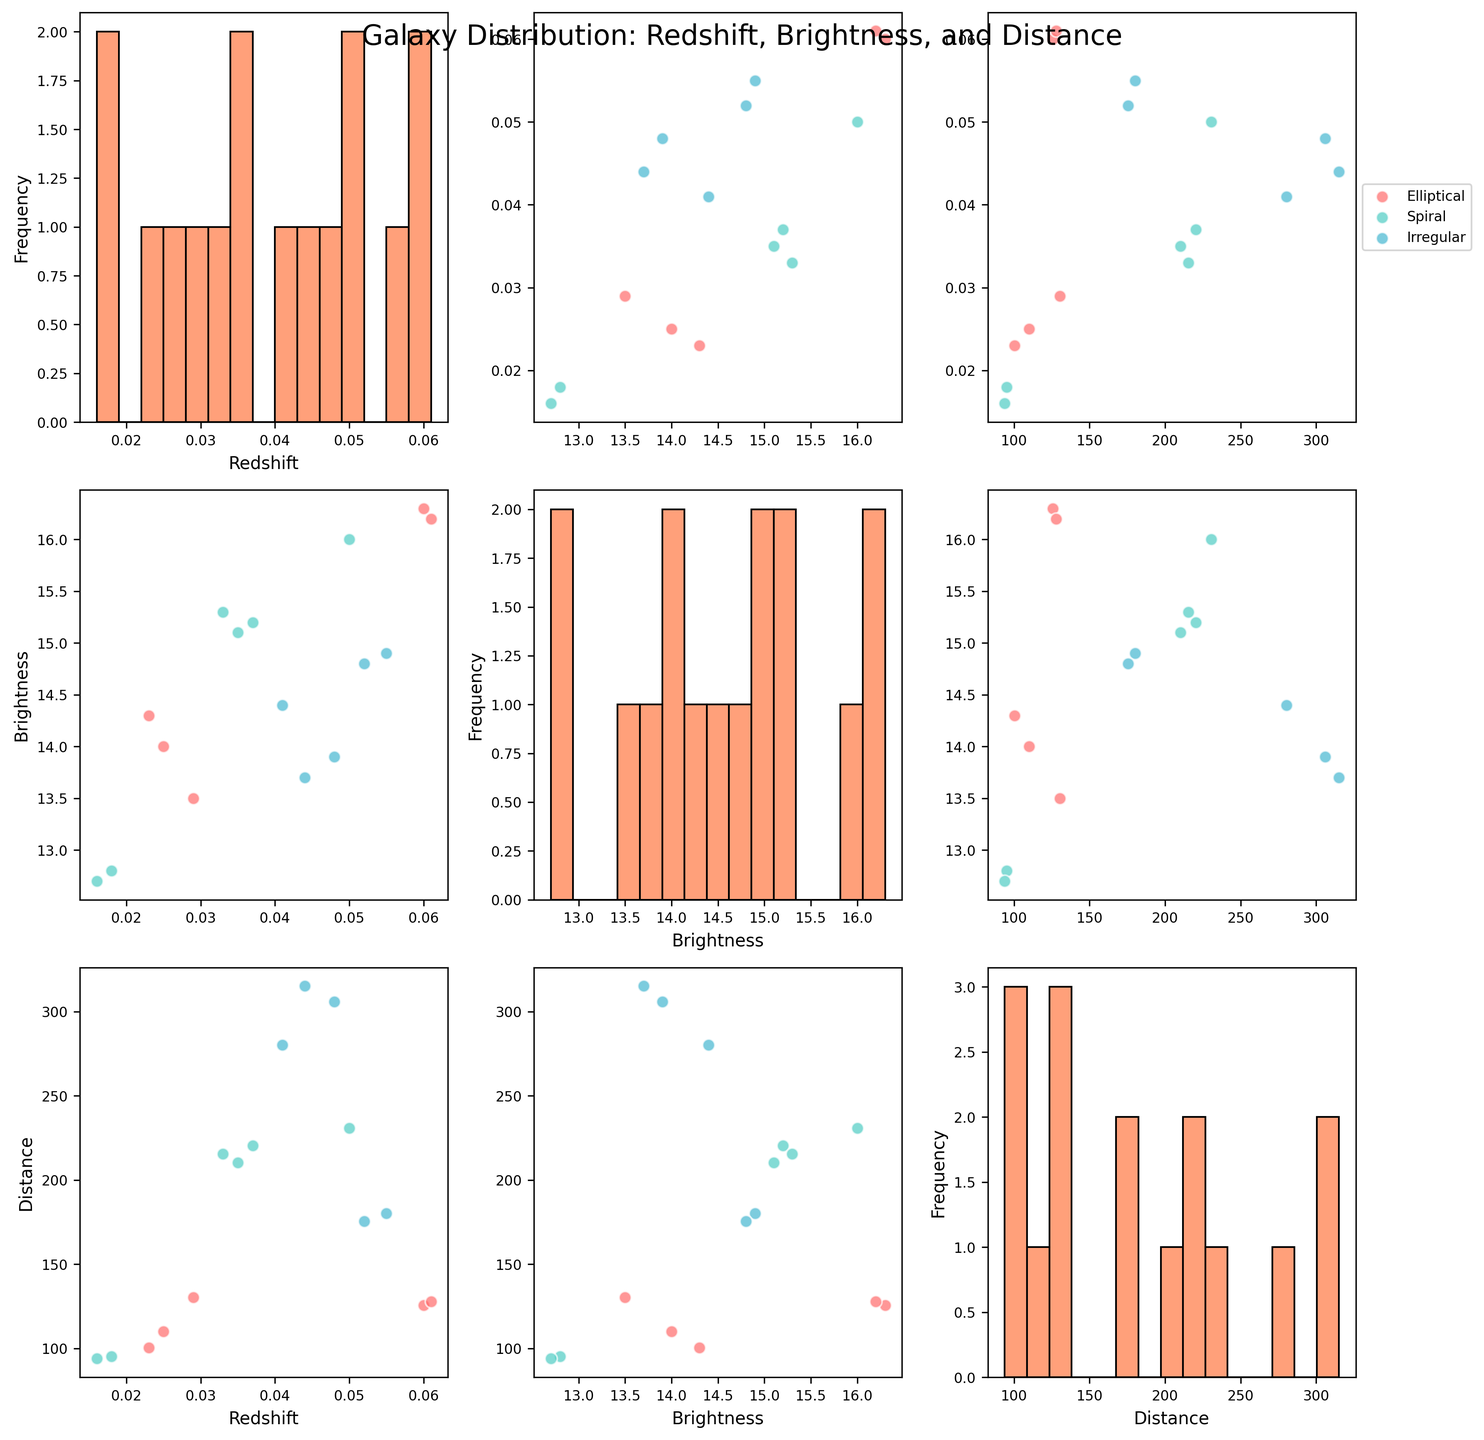What is the title of the scatter plot matrix? The title is typically placed at the top of the plot and is easy to identify in the figure. The title provides an overview of what the scatter plot matrix represents.
Answer: Galaxy Distribution: Redshift, Brightness, and Distance What color is used to represent Irregular galaxies? The figure uses different colors to represent galaxy types. The color for Irregular galaxies can be identified by looking at the legend in the top-right subplot.
Answer: A shade of blue How many histograms are present in the scatter plot matrix? The scatter plot matrix has histograms on its diagonal elements. By counting the main diagonal cells, you can determine the number of histograms.
Answer: 3 Which galaxy type generally has the highest distance values? By comparing the scatter plots involving the Distance axis for all galaxy types, you can identify which type reaches the highest values.
Answer: Irregular How does Brightness typically vary with Redshift for Spiral galaxies? To answer this, focus on the scatter plot of Brightness vs. Redshift specifically for Spiral galaxies, noting the trend.
Answer: Brightness generally increases with Redshift Which pair of variables has the widest spread for Elliptical galaxies? The spread can be observed by looking at the scatter plots involving Elliptical galaxies and comparing the distribution ranges across different pairs of variables.
Answer: Brightness vs. Distance Is there any noticeable clustering of data points for Spiral galaxies in the Redshift vs. Distance plot? Observing the scatter plot of Redshift vs. Distance for Spiral galaxies can indicate clusters based on closely packed data points.
Answer: Yes Compare the median Brightness of Elliptical galaxies to Spiral galaxies. To compare, find the median of Brightness for both Elliptical and Spiral galaxies from the relevant scatter plots or histograms and compare them.
Answer: Elliptical galaxies have a higher median Brightness Do any galaxy types exhibit a strong linear relationship between Distance and Redshift? Check the scatter plots of Distance vs. Redshift for each galaxy type to see if any exhibit a clear linear trend.
Answer: No How do the distributions of Redshift compare among all galaxy types? By examining the histograms of Redshift for each galaxy type, you can compare their distributions, noting any similarities or differences.
Answer: Elliptical galaxies have lower Redshift distribution than others 